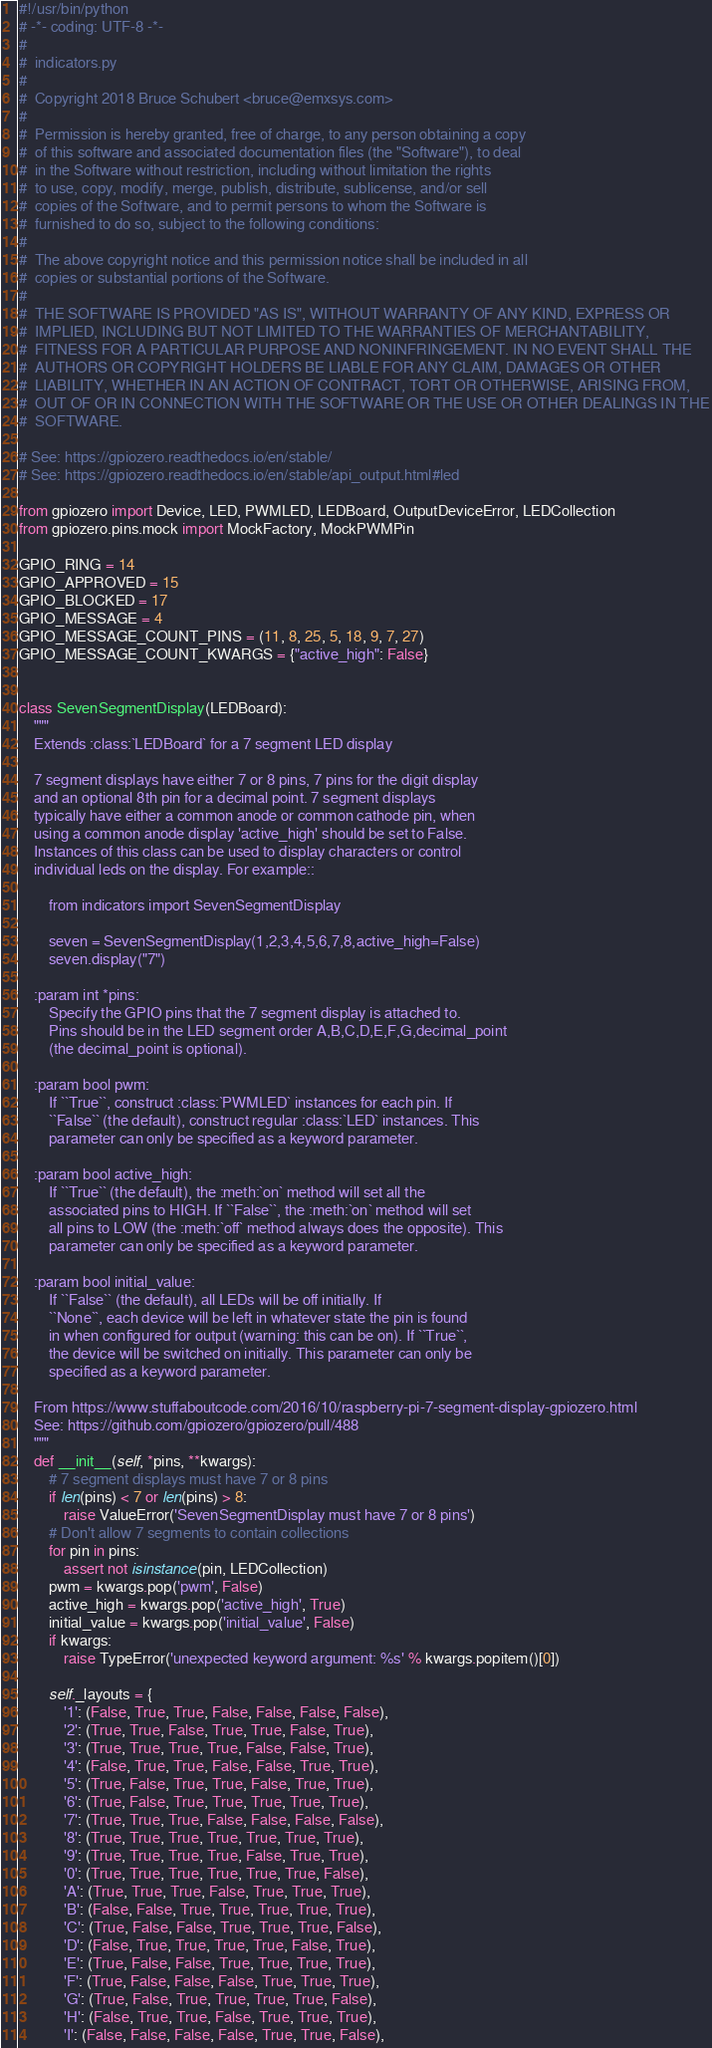<code> <loc_0><loc_0><loc_500><loc_500><_Python_>#!/usr/bin/python
# -*- coding: UTF-8 -*-
#
#  indicators.py
#
#  Copyright 2018 Bruce Schubert <bruce@emxsys.com>
#
#  Permission is hereby granted, free of charge, to any person obtaining a copy
#  of this software and associated documentation files (the "Software"), to deal
#  in the Software without restriction, including without limitation the rights
#  to use, copy, modify, merge, publish, distribute, sublicense, and/or sell
#  copies of the Software, and to permit persons to whom the Software is
#  furnished to do so, subject to the following conditions:
#
#  The above copyright notice and this permission notice shall be included in all
#  copies or substantial portions of the Software.
#
#  THE SOFTWARE IS PROVIDED "AS IS", WITHOUT WARRANTY OF ANY KIND, EXPRESS OR
#  IMPLIED, INCLUDING BUT NOT LIMITED TO THE WARRANTIES OF MERCHANTABILITY,
#  FITNESS FOR A PARTICULAR PURPOSE AND NONINFRINGEMENT. IN NO EVENT SHALL THE
#  AUTHORS OR COPYRIGHT HOLDERS BE LIABLE FOR ANY CLAIM, DAMAGES OR OTHER
#  LIABILITY, WHETHER IN AN ACTION OF CONTRACT, TORT OR OTHERWISE, ARISING FROM,
#  OUT OF OR IN CONNECTION WITH THE SOFTWARE OR THE USE OR OTHER DEALINGS IN THE
#  SOFTWARE.

# See: https://gpiozero.readthedocs.io/en/stable/
# See: https://gpiozero.readthedocs.io/en/stable/api_output.html#led

from gpiozero import Device, LED, PWMLED, LEDBoard, OutputDeviceError, LEDCollection
from gpiozero.pins.mock import MockFactory, MockPWMPin

GPIO_RING = 14
GPIO_APPROVED = 15
GPIO_BLOCKED = 17
GPIO_MESSAGE = 4
GPIO_MESSAGE_COUNT_PINS = (11, 8, 25, 5, 18, 9, 7, 27)
GPIO_MESSAGE_COUNT_KWARGS = {"active_high": False}


class SevenSegmentDisplay(LEDBoard):
    """
    Extends :class:`LEDBoard` for a 7 segment LED display

    7 segment displays have either 7 or 8 pins, 7 pins for the digit display
    and an optional 8th pin for a decimal point. 7 segment displays
    typically have either a common anode or common cathode pin, when
    using a common anode display 'active_high' should be set to False.
    Instances of this class can be used to display characters or control
    individual leds on the display. For example::

        from indicators import SevenSegmentDisplay

        seven = SevenSegmentDisplay(1,2,3,4,5,6,7,8,active_high=False)
        seven.display("7")

    :param int *pins:
        Specify the GPIO pins that the 7 segment display is attached to.
        Pins should be in the LED segment order A,B,C,D,E,F,G,decimal_point
        (the decimal_point is optional).

    :param bool pwm:
        If ``True``, construct :class:`PWMLED` instances for each pin. If
        ``False`` (the default), construct regular :class:`LED` instances. This
        parameter can only be specified as a keyword parameter.

    :param bool active_high:
        If ``True`` (the default), the :meth:`on` method will set all the
        associated pins to HIGH. If ``False``, the :meth:`on` method will set
        all pins to LOW (the :meth:`off` method always does the opposite). This
        parameter can only be specified as a keyword parameter.

    :param bool initial_value:
        If ``False`` (the default), all LEDs will be off initially. If
        ``None``, each device will be left in whatever state the pin is found
        in when configured for output (warning: this can be on). If ``True``,
        the device will be switched on initially. This parameter can only be
        specified as a keyword parameter.

    From https://www.stuffaboutcode.com/2016/10/raspberry-pi-7-segment-display-gpiozero.html
    See: https://github.com/gpiozero/gpiozero/pull/488
    """
    def __init__(self, *pins, **kwargs):
        # 7 segment displays must have 7 or 8 pins
        if len(pins) < 7 or len(pins) > 8:
            raise ValueError('SevenSegmentDisplay must have 7 or 8 pins')
        # Don't allow 7 segments to contain collections
        for pin in pins:
            assert not isinstance(pin, LEDCollection)
        pwm = kwargs.pop('pwm', False)
        active_high = kwargs.pop('active_high', True)
        initial_value = kwargs.pop('initial_value', False)
        if kwargs:
            raise TypeError('unexpected keyword argument: %s' % kwargs.popitem()[0])

        self._layouts = {
            '1': (False, True, True, False, False, False, False),
            '2': (True, True, False, True, True, False, True),
            '3': (True, True, True, True, False, False, True),
            '4': (False, True, True, False, False, True, True),
            '5': (True, False, True, True, False, True, True),
            '6': (True, False, True, True, True, True, True),
            '7': (True, True, True, False, False, False, False),
            '8': (True, True, True, True, True, True, True),
            '9': (True, True, True, True, False, True, True),
            '0': (True, True, True, True, True, True, False),
            'A': (True, True, True, False, True, True, True),
            'B': (False, False, True, True, True, True, True),
            'C': (True, False, False, True, True, True, False),
            'D': (False, True, True, True, True, False, True),
            'E': (True, False, False, True, True, True, True),
            'F': (True, False, False, False, True, True, True),
            'G': (True, False, True, True, True, True, False),
            'H': (False, True, True, False, True, True, True),
            'I': (False, False, False, False, True, True, False),</code> 